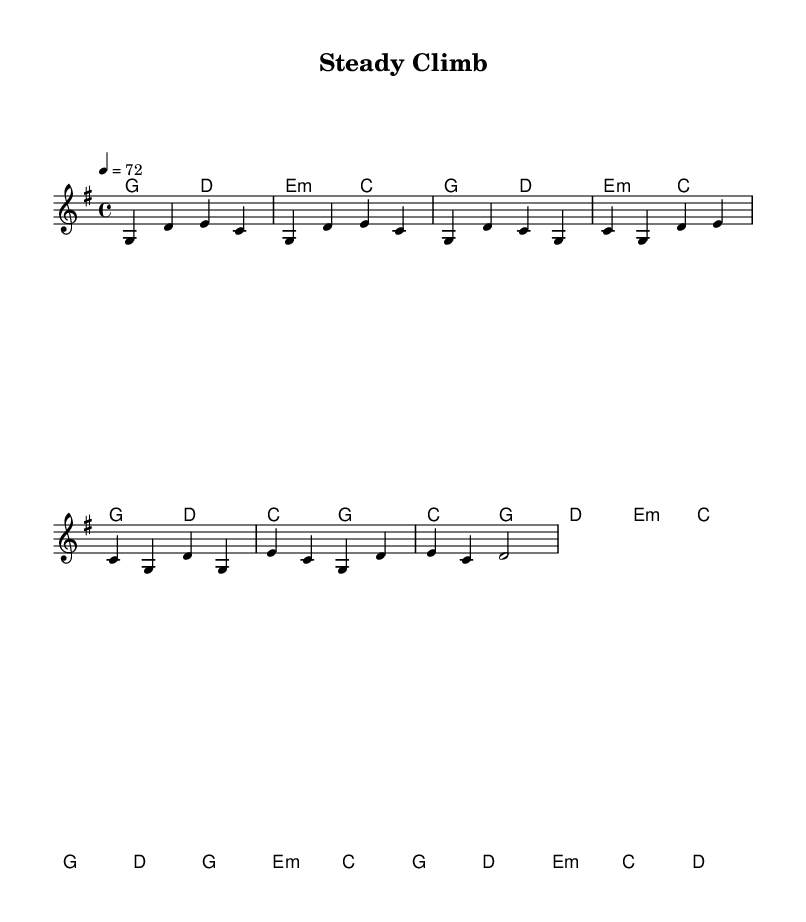What is the key signature of this music? The key signature is G major, which features one sharp (F#). This can be determined by looking at the key signature indicated at the beginning of the score.
Answer: G major What is the time signature of this music? The time signature is 4/4, which means there are four beats in each measure and each quarter note gets one beat. This is indicated at the beginning of the piece.
Answer: 4/4 What is the tempo marking for this music? The tempo marking is 72 beats per minute. This is indicated by the term "4 = 72" at the beginning of the score, specifying the speed of the music.
Answer: 72 How many measures are in the chorus section? The chorus section consists of four measures, which can be counted by examining the sectional breaks in the provided music notation.
Answer: 4 Which section of the music includes the different chorus chords? The chorus chords appear beneath the melody in the "harmonies" section, and specific chords like C, G, D, and E minor can be seen directly in that section.
Answer: Chorus Does the music have a bridge? Yes, the music includes a bridge section, which presents a contrasting musical idea and can be identified by the specific notation labeled as "Bridge" in the structure of the piece.
Answer: Yes What type of song structure does this music follow? The music follows a verse-chorus structure, which is common in country music, as denoted by the labeled sections in the score.
Answer: Verse-Chorus 